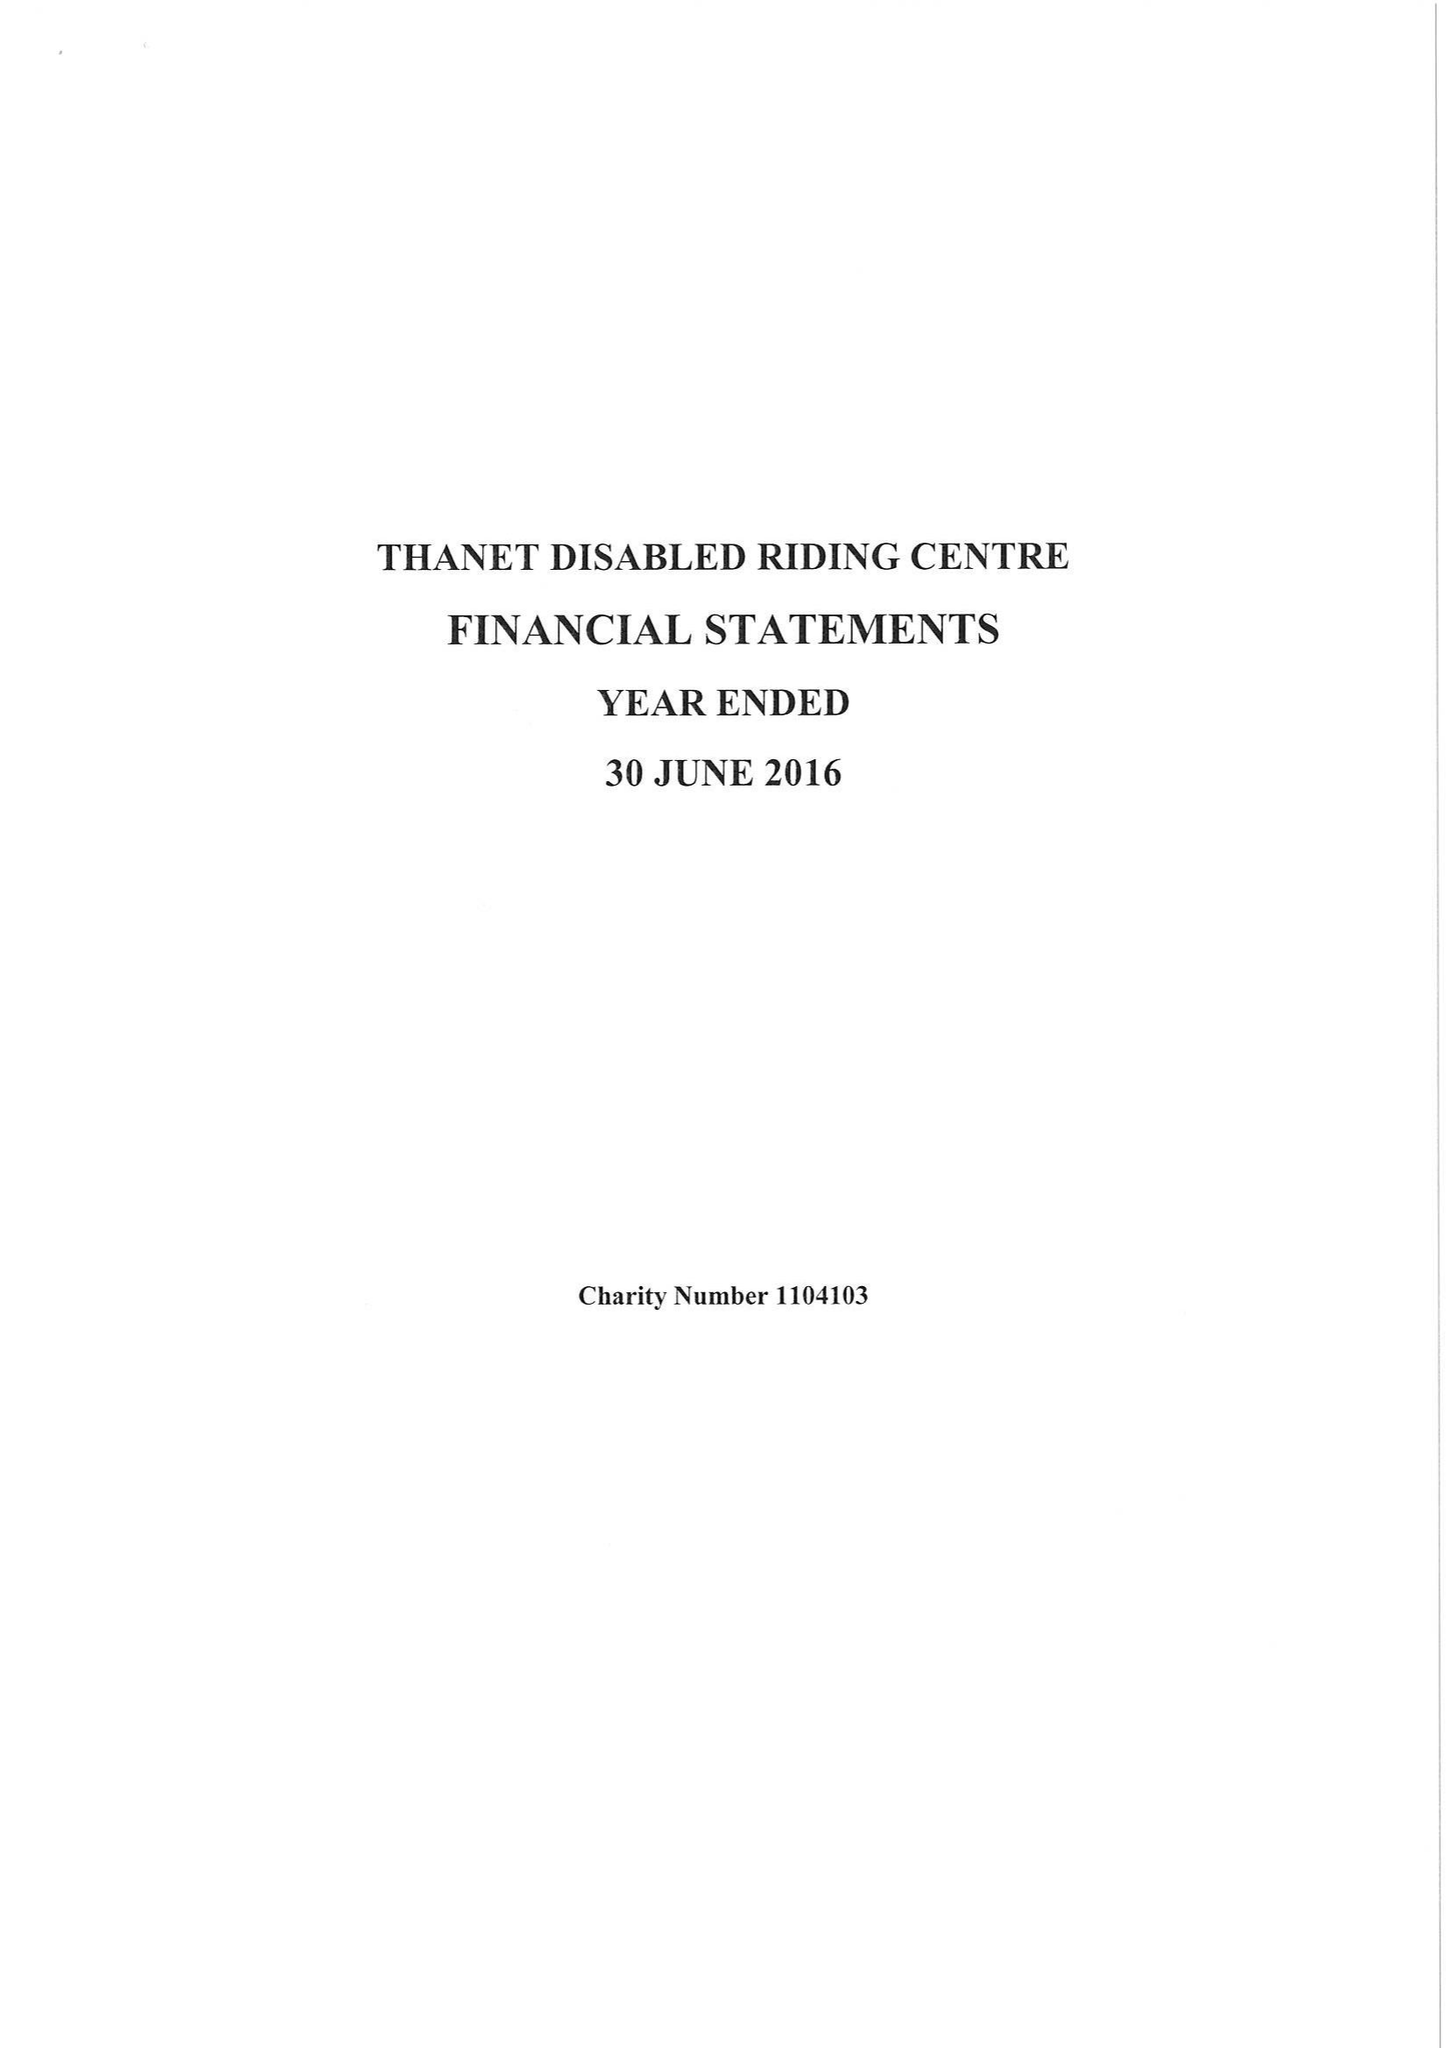What is the value for the charity_name?
Answer the question using a single word or phrase. Thanet Disabled Riding Centre 